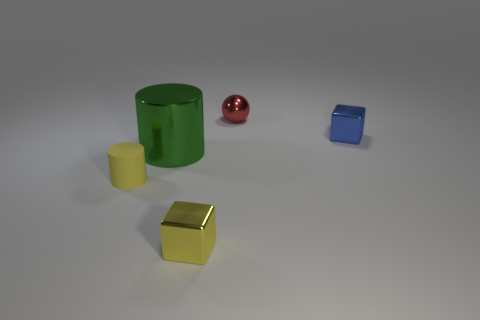There is a object left of the big metal thing; is its size the same as the metal cube that is behind the yellow rubber cylinder?
Ensure brevity in your answer.  Yes. How many objects are either big cyan matte things or yellow matte things?
Provide a succinct answer. 1. There is a metallic cube that is on the left side of the small blue block; how big is it?
Make the answer very short. Small. What number of yellow matte objects are to the right of the tiny metallic block behind the cylinder to the right of the tiny yellow matte cylinder?
Offer a terse response. 0. Do the metal sphere and the matte object have the same color?
Provide a short and direct response. No. What number of small things are both behind the tiny yellow cube and to the left of the tiny ball?
Keep it short and to the point. 1. There is a yellow object that is on the right side of the matte thing; what shape is it?
Provide a short and direct response. Cube. Are there fewer small blue metallic cubes that are on the left side of the tiny yellow cube than tiny yellow shiny cubes behind the small matte cylinder?
Offer a very short reply. No. Are the small block that is to the left of the blue shiny cube and the small thing to the right of the red thing made of the same material?
Give a very brief answer. Yes. The small red object has what shape?
Provide a short and direct response. Sphere. 